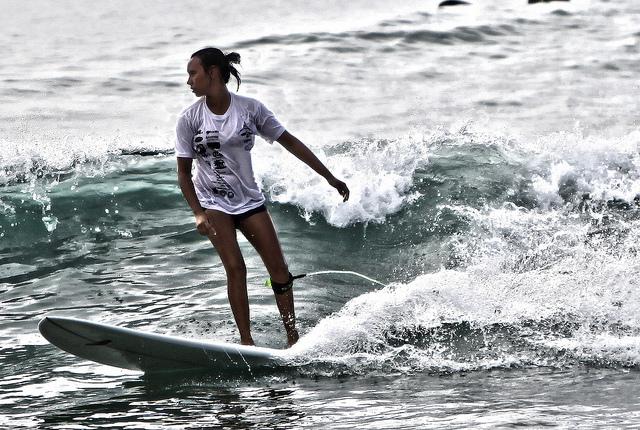What is the woman riding?
Concise answer only. Surfboard. Is the woman's left arm tied to the surfboard?
Short answer required. No. Where is the board strap?
Write a very short answer. Leg. 